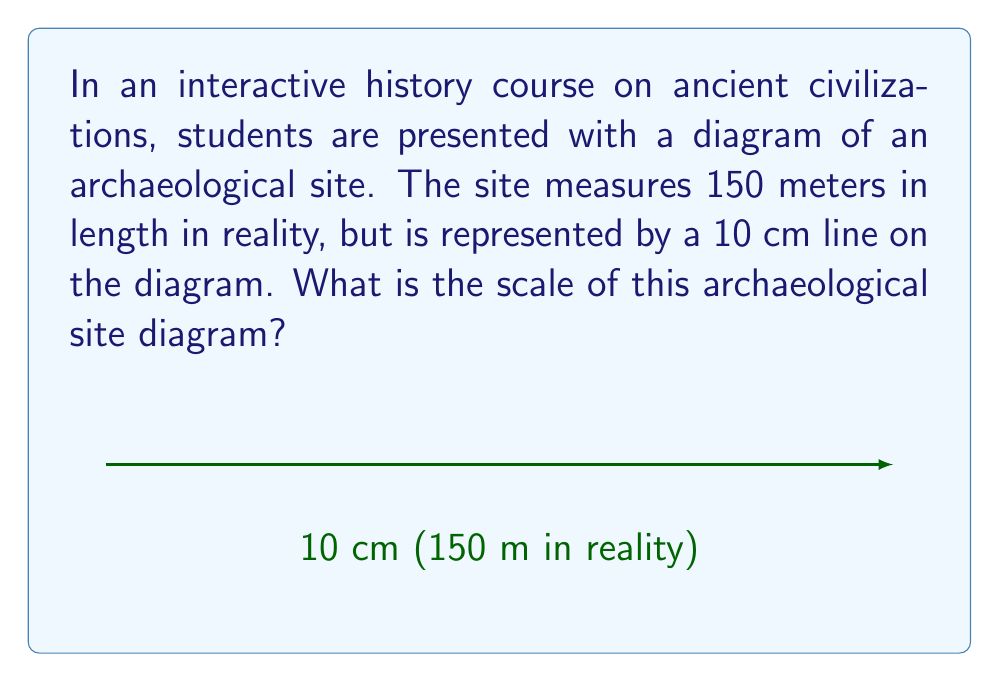Help me with this question. To determine the scale of the archaeological site diagram, we need to follow these steps:

1) First, we need to express both measurements in the same unit. Let's convert meters to centimeters:
   150 meters = 15,000 centimeters

2) Now we have:
   15,000 cm in reality is represented by 10 cm on the diagram

3) To find the scale, we need to determine how many centimeters in reality are represented by 1 cm on the diagram. We can set up the following proportion:

   $$\frac{15,000 \text{ cm (reality)}}{10 \text{ cm (diagram)}} = \frac{x \text{ cm (reality)}}{1 \text{ cm (diagram)}}$$

4) Cross multiply:
   $$15,000 * 1 = 10x$$

5) Solve for x:
   $$x = \frac{15,000}{10} = 1,500$$

6) This means that 1 cm on the diagram represents 1,500 cm in reality.

7) To express this as a scale, we write it as a ratio of 1 : 1,500

Therefore, the scale of the archaeological site diagram is 1 : 1,500.
Answer: 1 : 1,500 